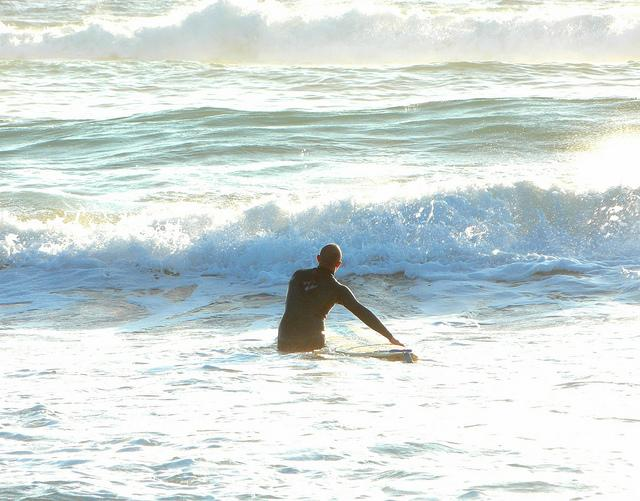World surf league is the highest governing body of which sport? Please explain your reasoning. surfing. The word is in the name 